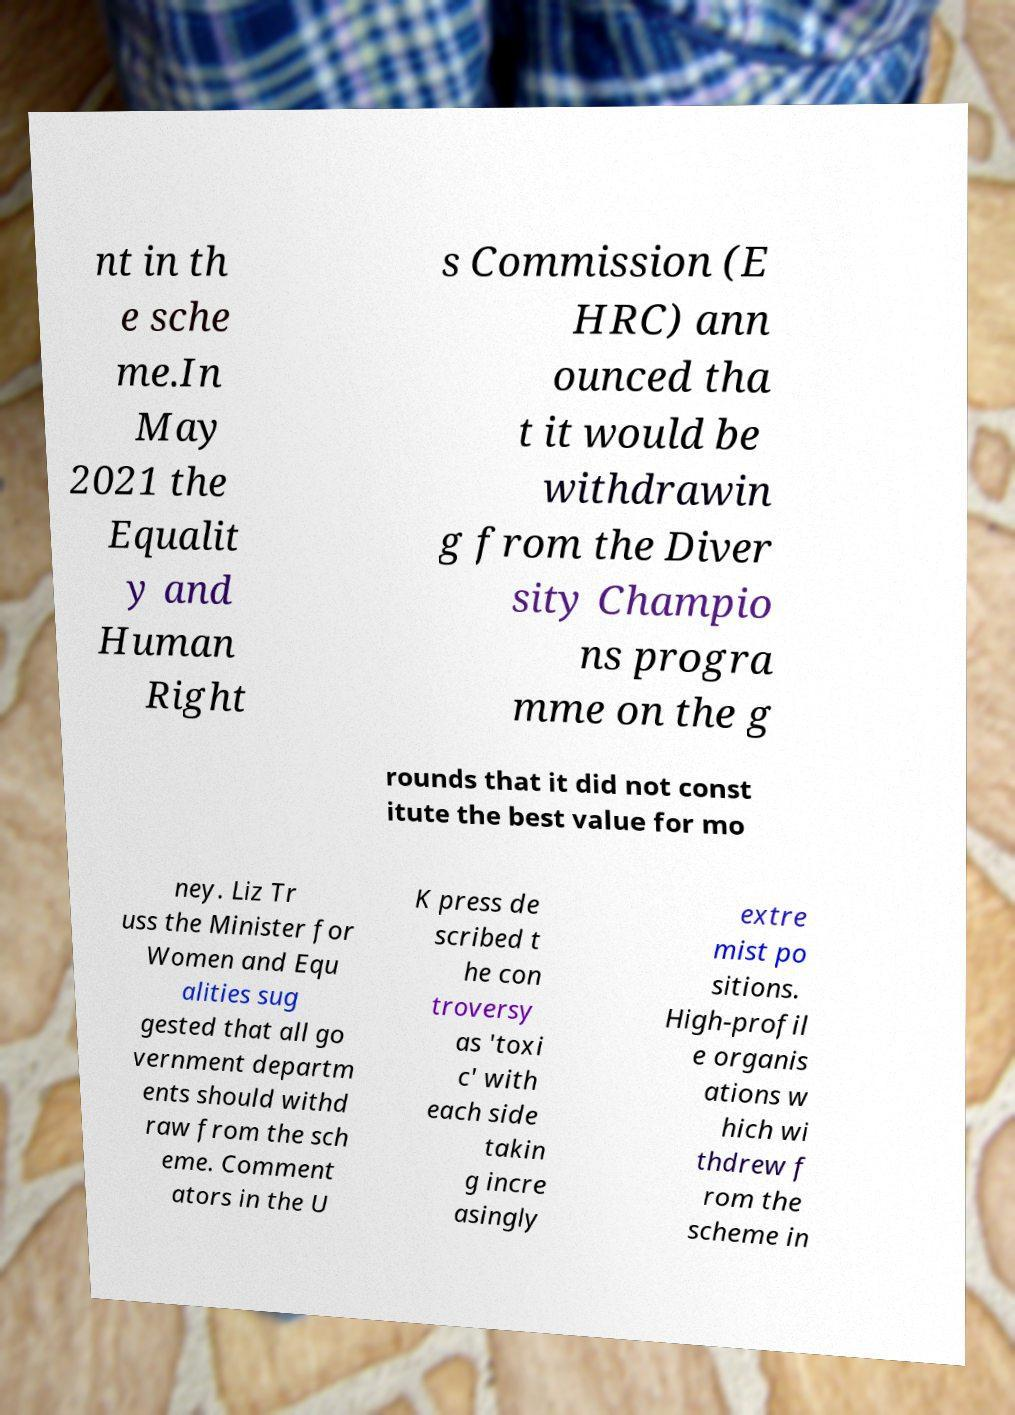Can you accurately transcribe the text from the provided image for me? nt in th e sche me.In May 2021 the Equalit y and Human Right s Commission (E HRC) ann ounced tha t it would be withdrawin g from the Diver sity Champio ns progra mme on the g rounds that it did not const itute the best value for mo ney. Liz Tr uss the Minister for Women and Equ alities sug gested that all go vernment departm ents should withd raw from the sch eme. Comment ators in the U K press de scribed t he con troversy as 'toxi c' with each side takin g incre asingly extre mist po sitions. High-profil e organis ations w hich wi thdrew f rom the scheme in 